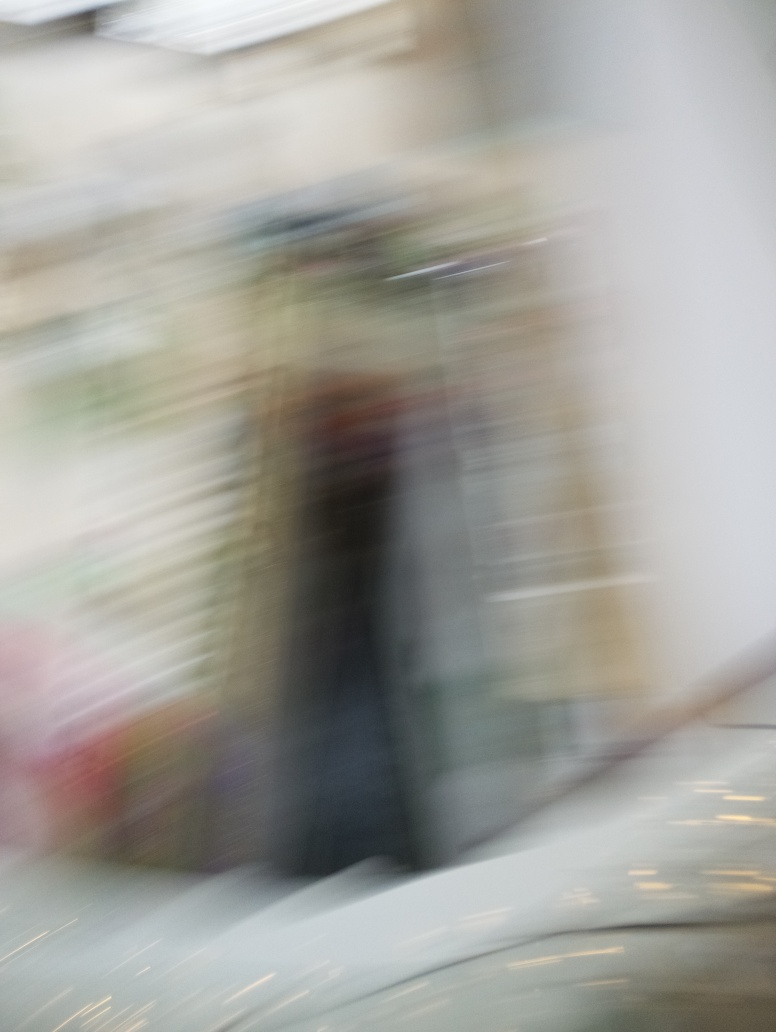What could be done to prevent this kind of blur in a photograph? To prevent this type of blur, one could use a faster shutter speed to shorten the exposure time, ensuring that any movement is less likely to be captured. Additionally, using a tripod or image stabilization can help to keep the camera steady, and anticipating the motion by tracking the subject with the camera can also reduce the blur effect. 